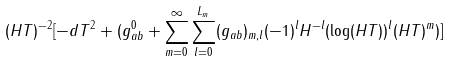<formula> <loc_0><loc_0><loc_500><loc_500>( H T ) ^ { - 2 } [ - d T ^ { 2 } + ( g ^ { 0 } _ { a b } + \sum _ { m = 0 } ^ { \infty } \sum _ { l = 0 } ^ { L _ { m } } ( g _ { a b } ) _ { m , l } ( - 1 ) ^ { l } H ^ { - l } ( \log ( H T ) ) ^ { l } ( H T ) ^ { m } ) ]</formula> 